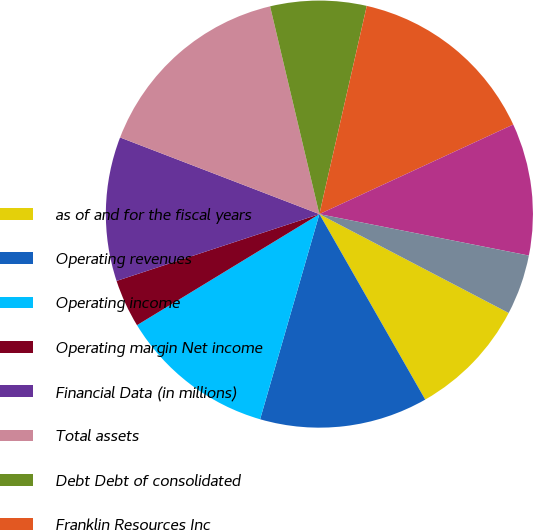<chart> <loc_0><loc_0><loc_500><loc_500><pie_chart><fcel>as of and for the fiscal years<fcel>Operating revenues<fcel>Operating income<fcel>Operating margin Net income<fcel>Financial Data (in millions)<fcel>Total assets<fcel>Debt Debt of consolidated<fcel>Franklin Resources Inc<fcel>Operating cash flows<fcel>Investing cash flows<nl><fcel>9.09%<fcel>12.73%<fcel>11.82%<fcel>3.64%<fcel>10.91%<fcel>15.45%<fcel>7.27%<fcel>14.55%<fcel>10.0%<fcel>4.55%<nl></chart> 